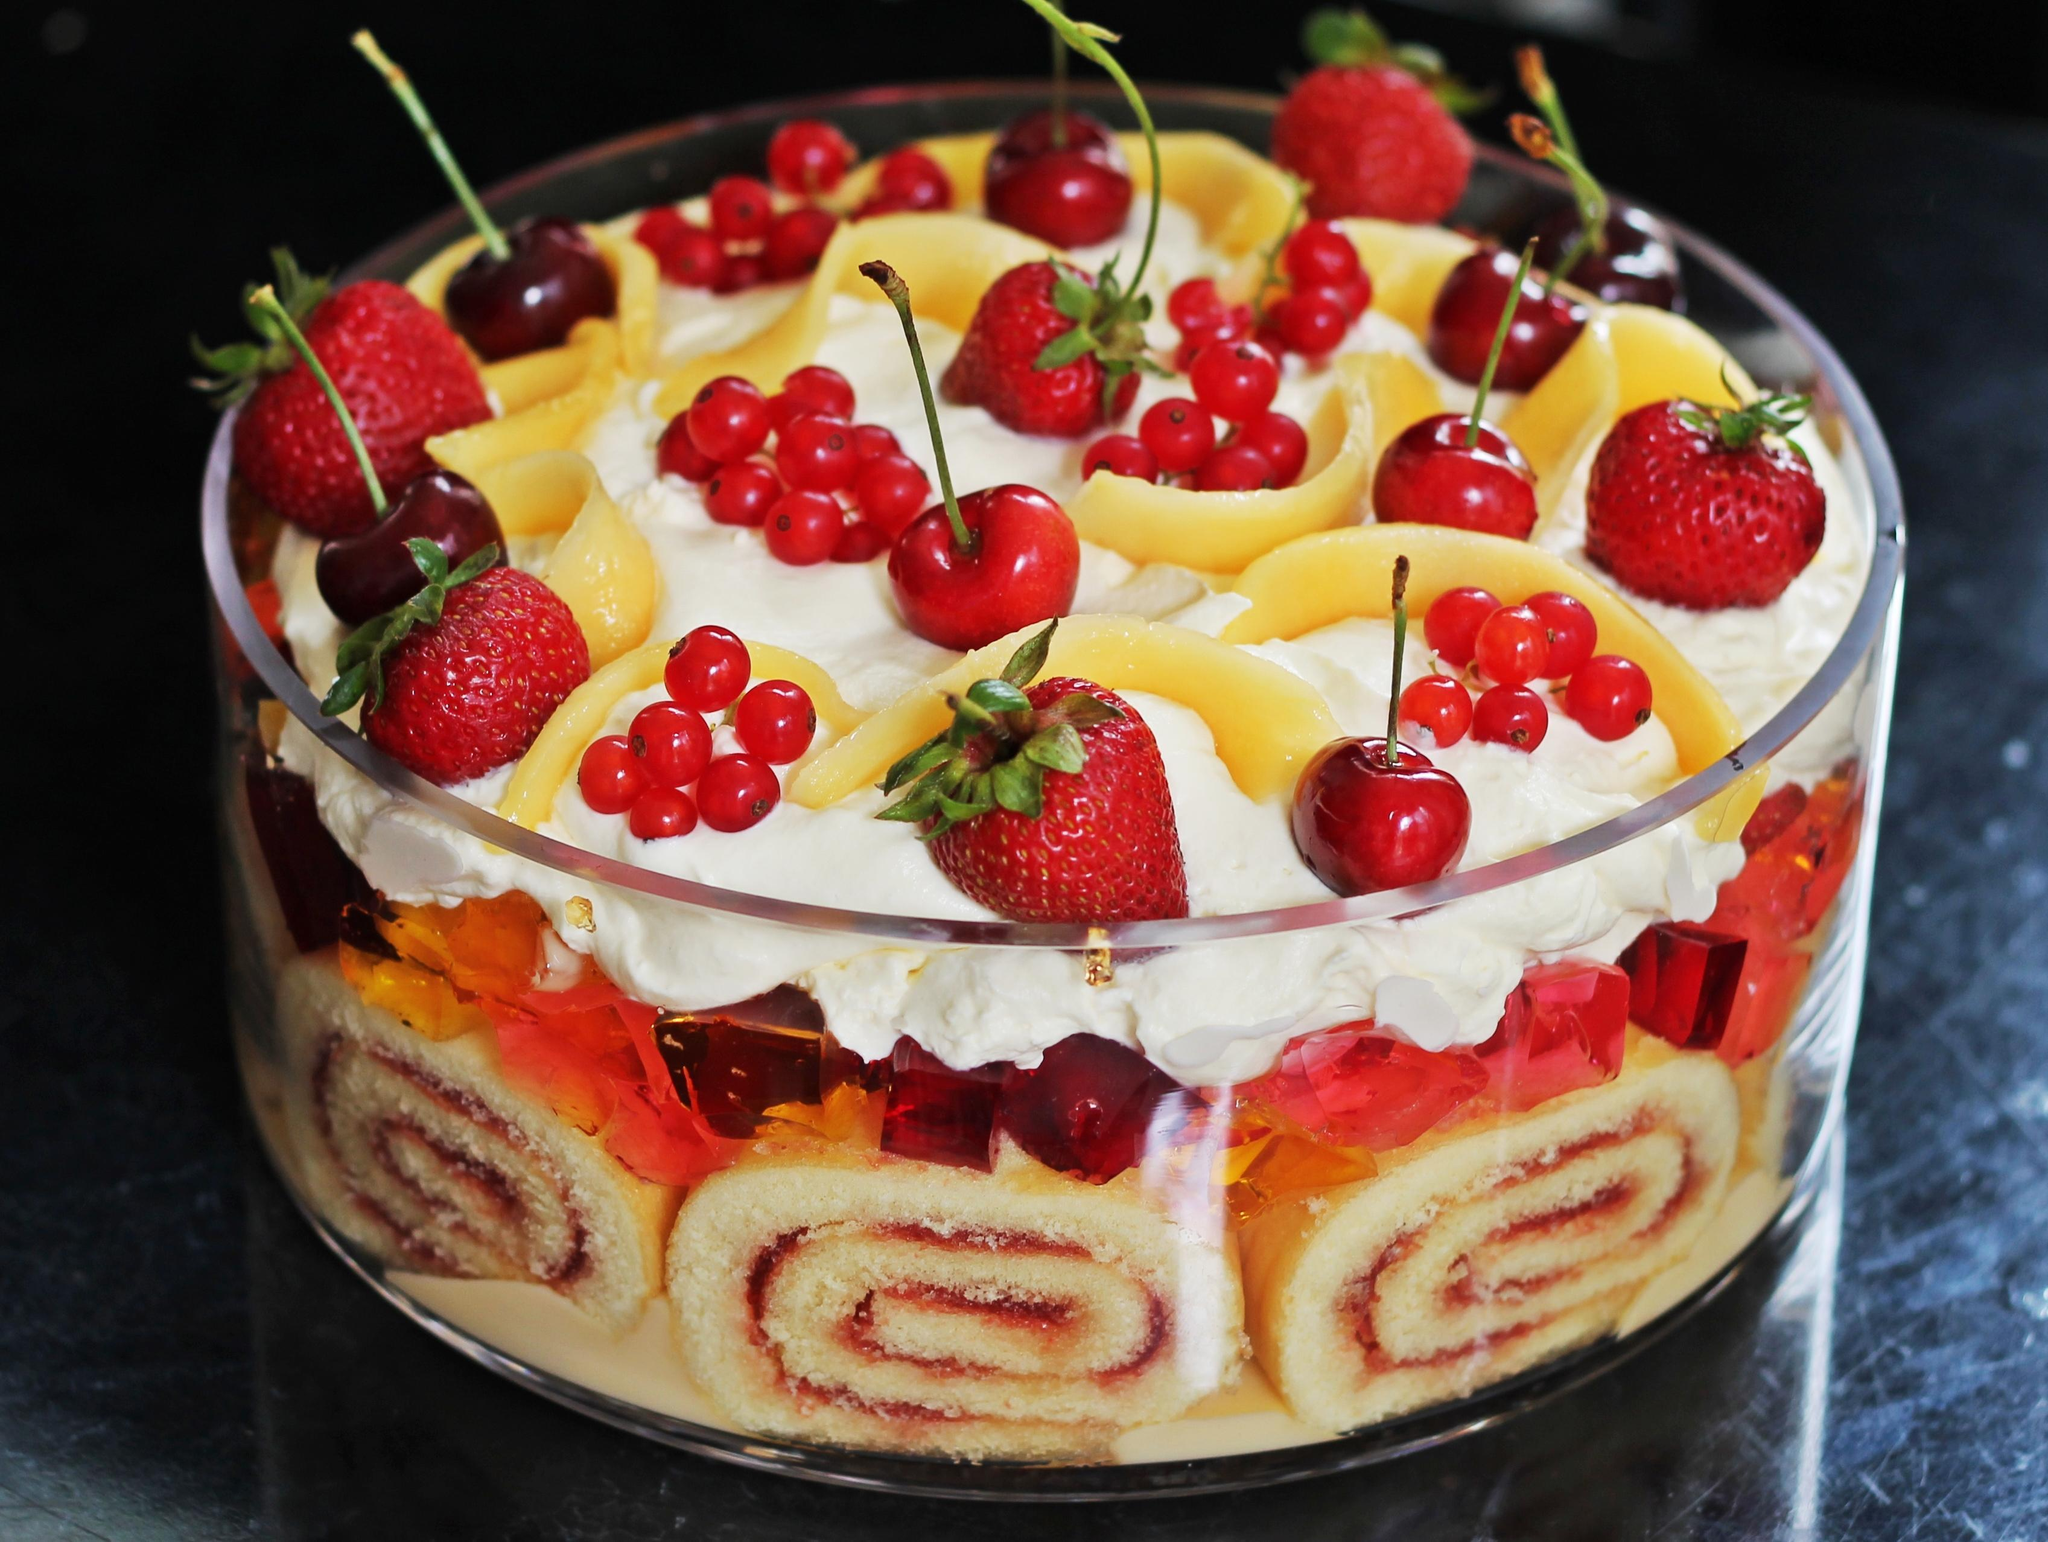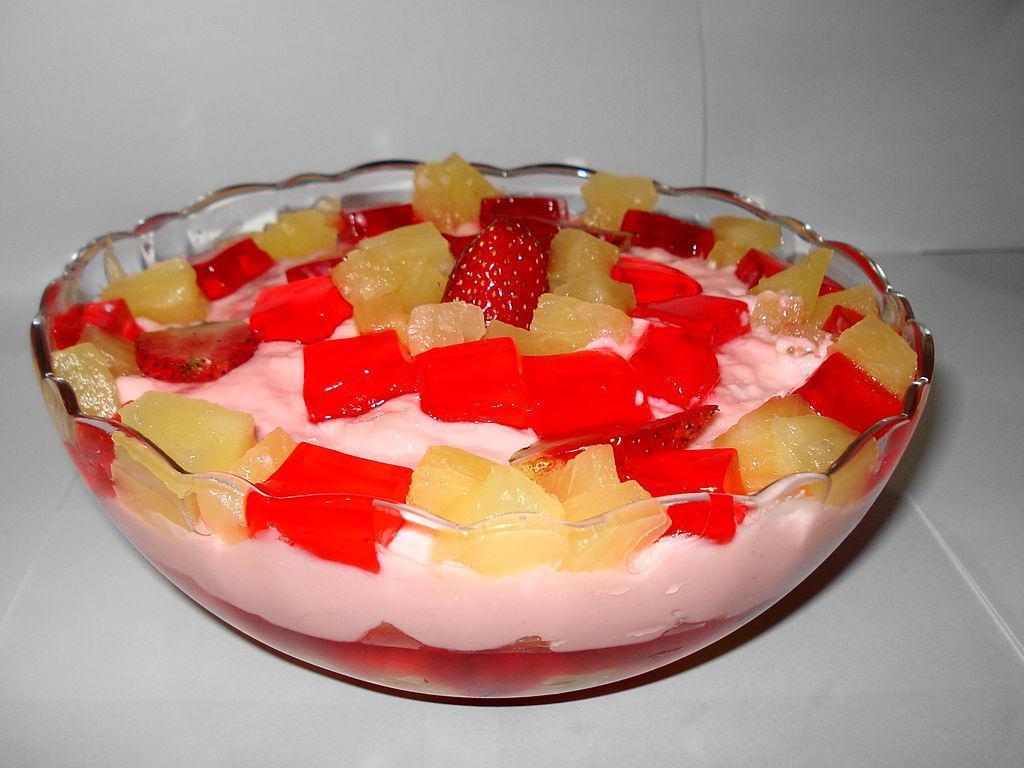The first image is the image on the left, the second image is the image on the right. For the images shown, is this caption "The desserts in the image on the left are being served in three glasses." true? Answer yes or no. No. The first image is the image on the left, the second image is the image on the right. Examine the images to the left and right. Is the description "Two large fruit and cream desserts are ready to serve in clear bowls and are garnished with red fruit." accurate? Answer yes or no. Yes. 